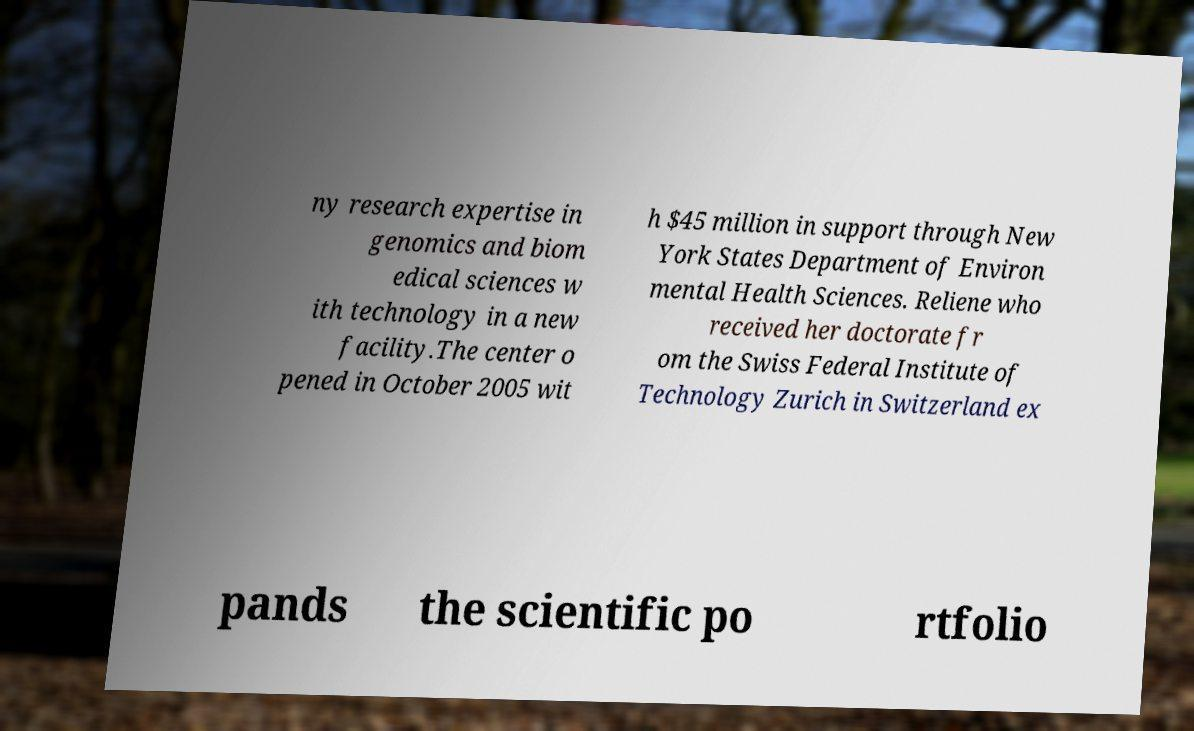What messages or text are displayed in this image? I need them in a readable, typed format. ny research expertise in genomics and biom edical sciences w ith technology in a new facility.The center o pened in October 2005 wit h $45 million in support through New York States Department of Environ mental Health Sciences. Reliene who received her doctorate fr om the Swiss Federal Institute of Technology Zurich in Switzerland ex pands the scientific po rtfolio 